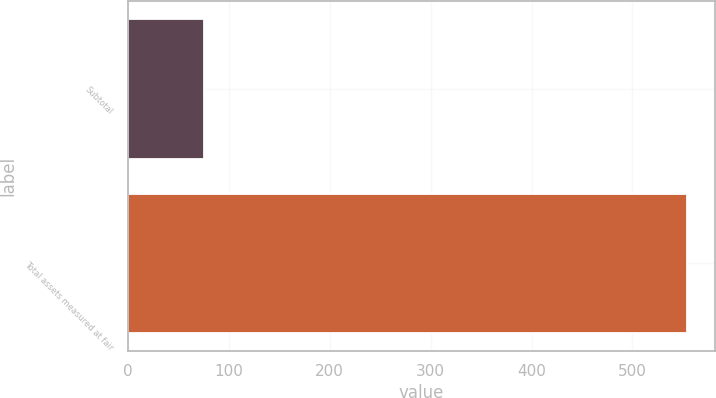Convert chart. <chart><loc_0><loc_0><loc_500><loc_500><bar_chart><fcel>Subtotal<fcel>Total assets measured at fair<nl><fcel>75.9<fcel>553.7<nl></chart> 